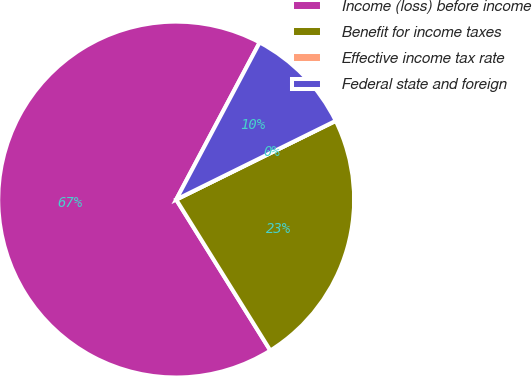Convert chart to OTSL. <chart><loc_0><loc_0><loc_500><loc_500><pie_chart><fcel>Income (loss) before income<fcel>Benefit for income taxes<fcel>Effective income tax rate<fcel>Federal state and foreign<nl><fcel>66.65%<fcel>23.42%<fcel>0.0%<fcel>9.93%<nl></chart> 